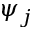Convert formula to latex. <formula><loc_0><loc_0><loc_500><loc_500>\psi _ { j }</formula> 